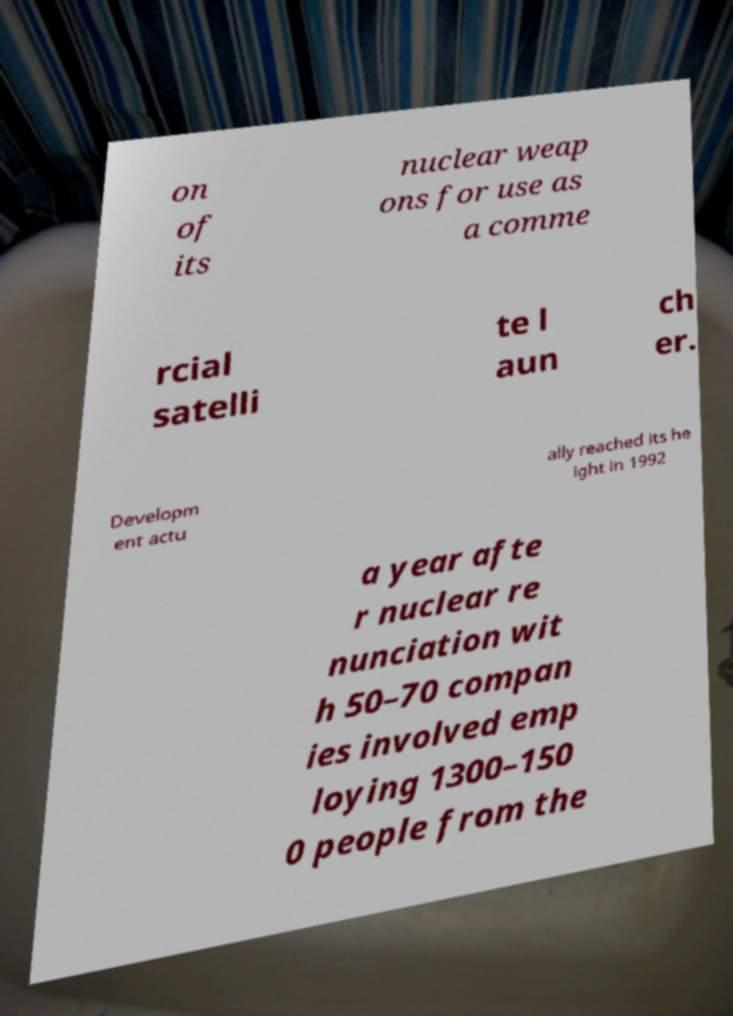Please read and relay the text visible in this image. What does it say? on of its nuclear weap ons for use as a comme rcial satelli te l aun ch er. Developm ent actu ally reached its he ight in 1992 a year afte r nuclear re nunciation wit h 50–70 compan ies involved emp loying 1300–150 0 people from the 